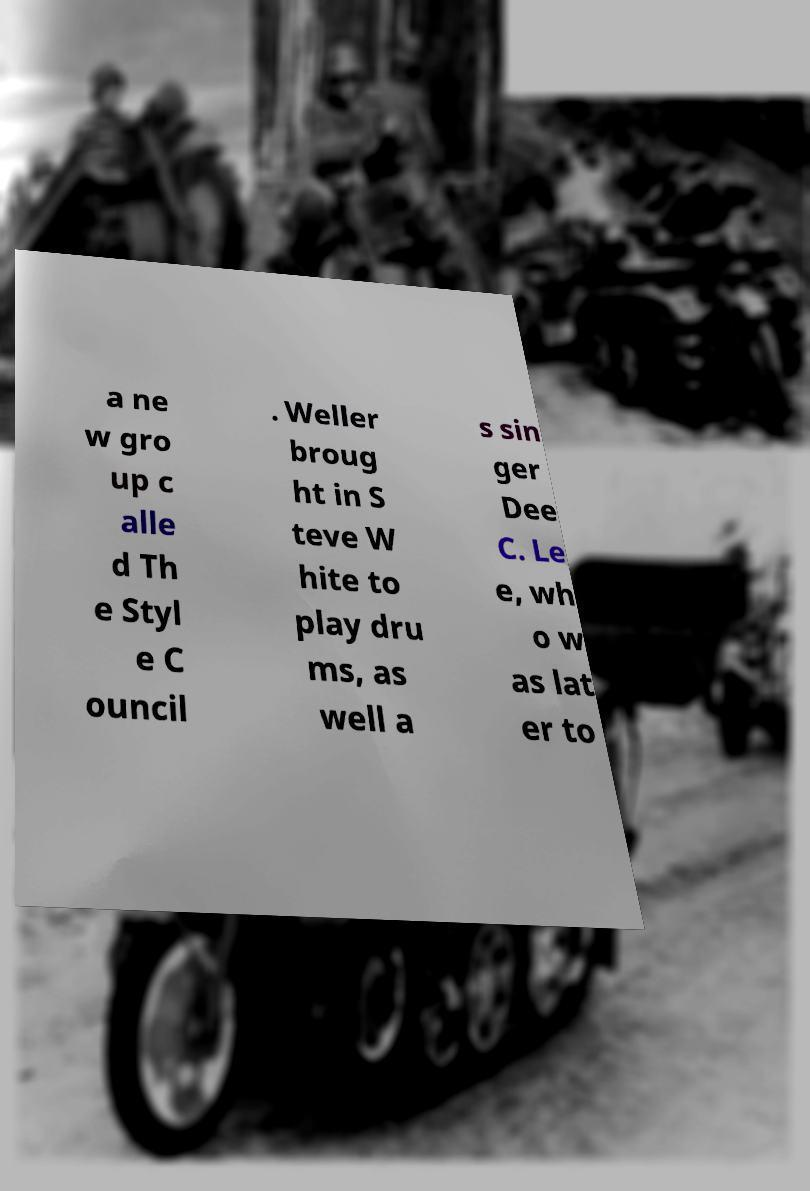What messages or text are displayed in this image? I need them in a readable, typed format. a ne w gro up c alle d Th e Styl e C ouncil . Weller broug ht in S teve W hite to play dru ms, as well a s sin ger Dee C. Le e, wh o w as lat er to 